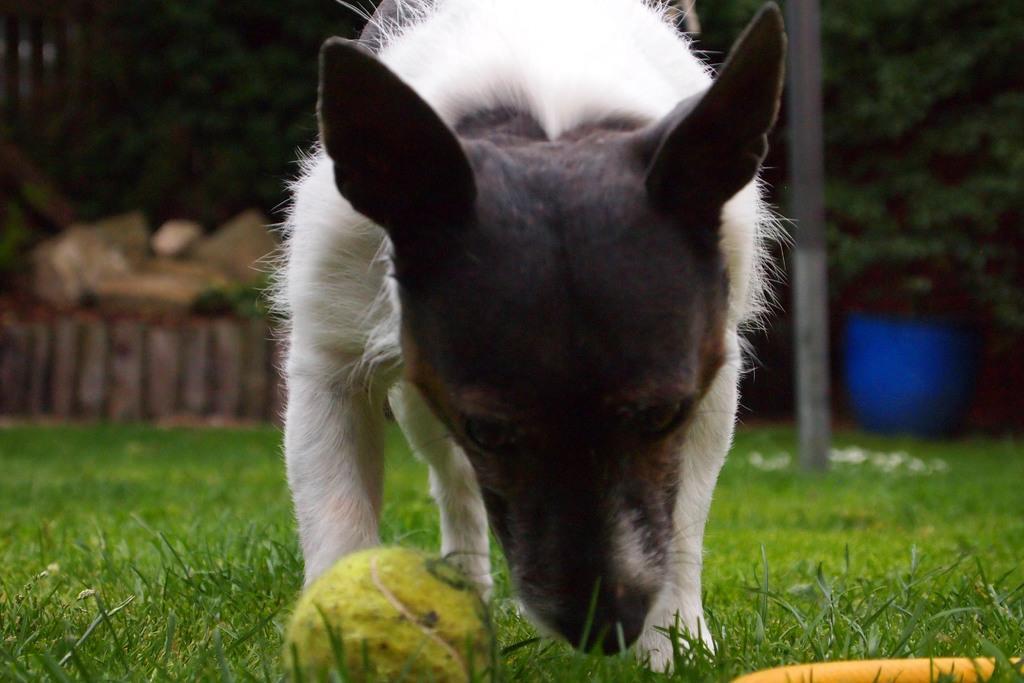Can you describe this image briefly? There is a dog,in front of this dog we can see a ball. In the background it is blurry and we can see trees and pole. 